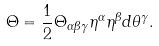<formula> <loc_0><loc_0><loc_500><loc_500>\Theta = \frac { 1 } { 2 } \Theta _ { \alpha \beta \gamma } \eta ^ { \alpha } \eta ^ { \beta } d \theta ^ { \gamma } .</formula> 